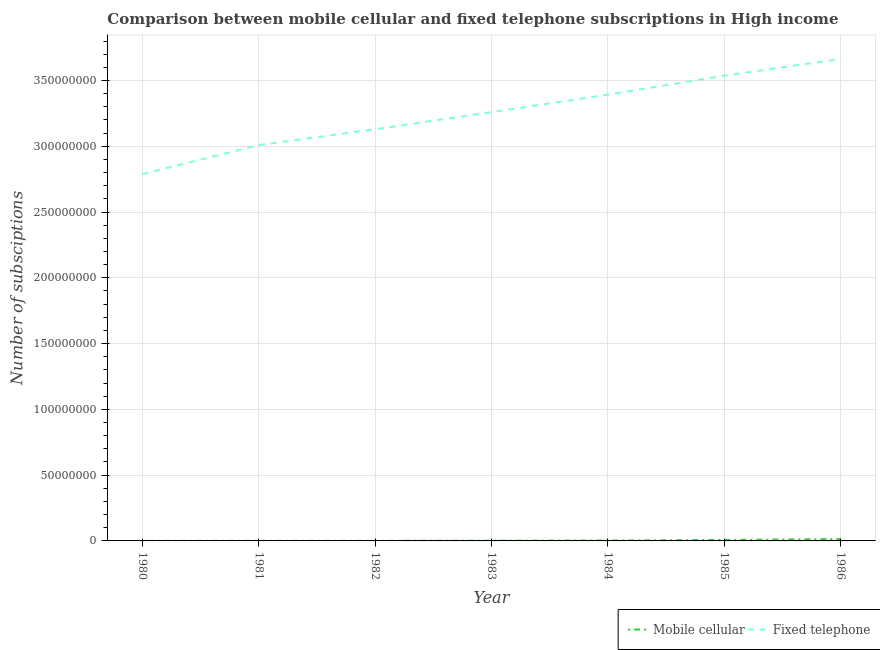What is the number of mobile cellular subscriptions in 1982?
Ensure brevity in your answer.  1.02e+05. Across all years, what is the maximum number of mobile cellular subscriptions?
Offer a terse response. 1.43e+06. Across all years, what is the minimum number of fixed telephone subscriptions?
Your answer should be very brief. 2.79e+08. In which year was the number of mobile cellular subscriptions maximum?
Offer a terse response. 1986. What is the total number of mobile cellular subscriptions in the graph?
Keep it short and to the point. 2.84e+06. What is the difference between the number of fixed telephone subscriptions in 1982 and that in 1986?
Your response must be concise. -5.34e+07. What is the difference between the number of mobile cellular subscriptions in 1980 and the number of fixed telephone subscriptions in 1986?
Your answer should be very brief. -3.66e+08. What is the average number of mobile cellular subscriptions per year?
Give a very brief answer. 4.05e+05. In the year 1980, what is the difference between the number of fixed telephone subscriptions and number of mobile cellular subscriptions?
Provide a short and direct response. 2.79e+08. What is the ratio of the number of fixed telephone subscriptions in 1983 to that in 1986?
Offer a very short reply. 0.89. Is the number of mobile cellular subscriptions in 1980 less than that in 1984?
Provide a short and direct response. Yes. Is the difference between the number of fixed telephone subscriptions in 1981 and 1983 greater than the difference between the number of mobile cellular subscriptions in 1981 and 1983?
Your answer should be compact. No. What is the difference between the highest and the second highest number of fixed telephone subscriptions?
Ensure brevity in your answer.  1.27e+07. What is the difference between the highest and the lowest number of fixed telephone subscriptions?
Provide a short and direct response. 8.75e+07. Is the sum of the number of fixed telephone subscriptions in 1980 and 1986 greater than the maximum number of mobile cellular subscriptions across all years?
Your response must be concise. Yes. What is the difference between two consecutive major ticks on the Y-axis?
Offer a very short reply. 5.00e+07. Are the values on the major ticks of Y-axis written in scientific E-notation?
Offer a very short reply. No. Does the graph contain any zero values?
Offer a terse response. No. Does the graph contain grids?
Provide a succinct answer. Yes. Where does the legend appear in the graph?
Your response must be concise. Bottom right. How many legend labels are there?
Your response must be concise. 2. What is the title of the graph?
Keep it short and to the point. Comparison between mobile cellular and fixed telephone subscriptions in High income. Does "Non-solid fuel" appear as one of the legend labels in the graph?
Ensure brevity in your answer.  No. What is the label or title of the X-axis?
Give a very brief answer. Year. What is the label or title of the Y-axis?
Provide a succinct answer. Number of subsciptions. What is the Number of subsciptions of Mobile cellular in 1980?
Give a very brief answer. 2.35e+04. What is the Number of subsciptions in Fixed telephone in 1980?
Offer a terse response. 2.79e+08. What is the Number of subsciptions in Mobile cellular in 1981?
Give a very brief answer. 6.36e+04. What is the Number of subsciptions of Fixed telephone in 1981?
Offer a very short reply. 3.01e+08. What is the Number of subsciptions in Mobile cellular in 1982?
Offer a terse response. 1.02e+05. What is the Number of subsciptions of Fixed telephone in 1982?
Keep it short and to the point. 3.13e+08. What is the Number of subsciptions of Mobile cellular in 1983?
Provide a succinct answer. 1.49e+05. What is the Number of subsciptions of Fixed telephone in 1983?
Provide a short and direct response. 3.26e+08. What is the Number of subsciptions of Mobile cellular in 1984?
Keep it short and to the point. 3.18e+05. What is the Number of subsciptions in Fixed telephone in 1984?
Offer a very short reply. 3.39e+08. What is the Number of subsciptions of Mobile cellular in 1985?
Your answer should be compact. 7.49e+05. What is the Number of subsciptions of Fixed telephone in 1985?
Offer a terse response. 3.54e+08. What is the Number of subsciptions in Mobile cellular in 1986?
Make the answer very short. 1.43e+06. What is the Number of subsciptions of Fixed telephone in 1986?
Offer a terse response. 3.66e+08. Across all years, what is the maximum Number of subsciptions in Mobile cellular?
Offer a very short reply. 1.43e+06. Across all years, what is the maximum Number of subsciptions in Fixed telephone?
Keep it short and to the point. 3.66e+08. Across all years, what is the minimum Number of subsciptions of Mobile cellular?
Make the answer very short. 2.35e+04. Across all years, what is the minimum Number of subsciptions of Fixed telephone?
Make the answer very short. 2.79e+08. What is the total Number of subsciptions in Mobile cellular in the graph?
Keep it short and to the point. 2.84e+06. What is the total Number of subsciptions of Fixed telephone in the graph?
Give a very brief answer. 2.28e+09. What is the difference between the Number of subsciptions of Mobile cellular in 1980 and that in 1981?
Make the answer very short. -4.01e+04. What is the difference between the Number of subsciptions of Fixed telephone in 1980 and that in 1981?
Offer a very short reply. -2.21e+07. What is the difference between the Number of subsciptions of Mobile cellular in 1980 and that in 1982?
Provide a succinct answer. -7.80e+04. What is the difference between the Number of subsciptions of Fixed telephone in 1980 and that in 1982?
Provide a short and direct response. -3.41e+07. What is the difference between the Number of subsciptions in Mobile cellular in 1980 and that in 1983?
Give a very brief answer. -1.25e+05. What is the difference between the Number of subsciptions of Fixed telephone in 1980 and that in 1983?
Offer a very short reply. -4.71e+07. What is the difference between the Number of subsciptions in Mobile cellular in 1980 and that in 1984?
Offer a very short reply. -2.94e+05. What is the difference between the Number of subsciptions of Fixed telephone in 1980 and that in 1984?
Your response must be concise. -6.04e+07. What is the difference between the Number of subsciptions in Mobile cellular in 1980 and that in 1985?
Make the answer very short. -7.25e+05. What is the difference between the Number of subsciptions in Fixed telephone in 1980 and that in 1985?
Your response must be concise. -7.48e+07. What is the difference between the Number of subsciptions in Mobile cellular in 1980 and that in 1986?
Your answer should be compact. -1.41e+06. What is the difference between the Number of subsciptions of Fixed telephone in 1980 and that in 1986?
Offer a very short reply. -8.75e+07. What is the difference between the Number of subsciptions of Mobile cellular in 1981 and that in 1982?
Give a very brief answer. -3.79e+04. What is the difference between the Number of subsciptions of Fixed telephone in 1981 and that in 1982?
Ensure brevity in your answer.  -1.21e+07. What is the difference between the Number of subsciptions in Mobile cellular in 1981 and that in 1983?
Your response must be concise. -8.53e+04. What is the difference between the Number of subsciptions in Fixed telephone in 1981 and that in 1983?
Your answer should be compact. -2.50e+07. What is the difference between the Number of subsciptions in Mobile cellular in 1981 and that in 1984?
Ensure brevity in your answer.  -2.54e+05. What is the difference between the Number of subsciptions of Fixed telephone in 1981 and that in 1984?
Offer a very short reply. -3.84e+07. What is the difference between the Number of subsciptions in Mobile cellular in 1981 and that in 1985?
Make the answer very short. -6.85e+05. What is the difference between the Number of subsciptions of Fixed telephone in 1981 and that in 1985?
Provide a succinct answer. -5.28e+07. What is the difference between the Number of subsciptions of Mobile cellular in 1981 and that in 1986?
Your response must be concise. -1.37e+06. What is the difference between the Number of subsciptions of Fixed telephone in 1981 and that in 1986?
Your answer should be compact. -6.55e+07. What is the difference between the Number of subsciptions of Mobile cellular in 1982 and that in 1983?
Keep it short and to the point. -4.73e+04. What is the difference between the Number of subsciptions of Fixed telephone in 1982 and that in 1983?
Offer a very short reply. -1.30e+07. What is the difference between the Number of subsciptions in Mobile cellular in 1982 and that in 1984?
Offer a terse response. -2.16e+05. What is the difference between the Number of subsciptions in Fixed telephone in 1982 and that in 1984?
Keep it short and to the point. -2.63e+07. What is the difference between the Number of subsciptions in Mobile cellular in 1982 and that in 1985?
Your answer should be compact. -6.47e+05. What is the difference between the Number of subsciptions in Fixed telephone in 1982 and that in 1985?
Give a very brief answer. -4.07e+07. What is the difference between the Number of subsciptions of Mobile cellular in 1982 and that in 1986?
Provide a short and direct response. -1.33e+06. What is the difference between the Number of subsciptions of Fixed telephone in 1982 and that in 1986?
Make the answer very short. -5.34e+07. What is the difference between the Number of subsciptions of Mobile cellular in 1983 and that in 1984?
Provide a succinct answer. -1.69e+05. What is the difference between the Number of subsciptions in Fixed telephone in 1983 and that in 1984?
Keep it short and to the point. -1.33e+07. What is the difference between the Number of subsciptions of Mobile cellular in 1983 and that in 1985?
Provide a succinct answer. -6.00e+05. What is the difference between the Number of subsciptions in Fixed telephone in 1983 and that in 1985?
Your response must be concise. -2.77e+07. What is the difference between the Number of subsciptions in Mobile cellular in 1983 and that in 1986?
Provide a short and direct response. -1.28e+06. What is the difference between the Number of subsciptions of Fixed telephone in 1983 and that in 1986?
Provide a short and direct response. -4.04e+07. What is the difference between the Number of subsciptions of Mobile cellular in 1984 and that in 1985?
Offer a terse response. -4.31e+05. What is the difference between the Number of subsciptions of Fixed telephone in 1984 and that in 1985?
Make the answer very short. -1.44e+07. What is the difference between the Number of subsciptions of Mobile cellular in 1984 and that in 1986?
Your answer should be compact. -1.12e+06. What is the difference between the Number of subsciptions in Fixed telephone in 1984 and that in 1986?
Keep it short and to the point. -2.71e+07. What is the difference between the Number of subsciptions in Mobile cellular in 1985 and that in 1986?
Provide a short and direct response. -6.85e+05. What is the difference between the Number of subsciptions in Fixed telephone in 1985 and that in 1986?
Your answer should be compact. -1.27e+07. What is the difference between the Number of subsciptions of Mobile cellular in 1980 and the Number of subsciptions of Fixed telephone in 1981?
Make the answer very short. -3.01e+08. What is the difference between the Number of subsciptions of Mobile cellular in 1980 and the Number of subsciptions of Fixed telephone in 1982?
Your response must be concise. -3.13e+08. What is the difference between the Number of subsciptions of Mobile cellular in 1980 and the Number of subsciptions of Fixed telephone in 1983?
Offer a very short reply. -3.26e+08. What is the difference between the Number of subsciptions of Mobile cellular in 1980 and the Number of subsciptions of Fixed telephone in 1984?
Ensure brevity in your answer.  -3.39e+08. What is the difference between the Number of subsciptions of Mobile cellular in 1980 and the Number of subsciptions of Fixed telephone in 1985?
Ensure brevity in your answer.  -3.54e+08. What is the difference between the Number of subsciptions in Mobile cellular in 1980 and the Number of subsciptions in Fixed telephone in 1986?
Provide a short and direct response. -3.66e+08. What is the difference between the Number of subsciptions of Mobile cellular in 1981 and the Number of subsciptions of Fixed telephone in 1982?
Your answer should be compact. -3.13e+08. What is the difference between the Number of subsciptions in Mobile cellular in 1981 and the Number of subsciptions in Fixed telephone in 1983?
Your answer should be compact. -3.26e+08. What is the difference between the Number of subsciptions in Mobile cellular in 1981 and the Number of subsciptions in Fixed telephone in 1984?
Offer a terse response. -3.39e+08. What is the difference between the Number of subsciptions of Mobile cellular in 1981 and the Number of subsciptions of Fixed telephone in 1985?
Give a very brief answer. -3.54e+08. What is the difference between the Number of subsciptions in Mobile cellular in 1981 and the Number of subsciptions in Fixed telephone in 1986?
Your answer should be compact. -3.66e+08. What is the difference between the Number of subsciptions of Mobile cellular in 1982 and the Number of subsciptions of Fixed telephone in 1983?
Your answer should be very brief. -3.26e+08. What is the difference between the Number of subsciptions in Mobile cellular in 1982 and the Number of subsciptions in Fixed telephone in 1984?
Your response must be concise. -3.39e+08. What is the difference between the Number of subsciptions in Mobile cellular in 1982 and the Number of subsciptions in Fixed telephone in 1985?
Provide a succinct answer. -3.54e+08. What is the difference between the Number of subsciptions of Mobile cellular in 1982 and the Number of subsciptions of Fixed telephone in 1986?
Ensure brevity in your answer.  -3.66e+08. What is the difference between the Number of subsciptions in Mobile cellular in 1983 and the Number of subsciptions in Fixed telephone in 1984?
Give a very brief answer. -3.39e+08. What is the difference between the Number of subsciptions of Mobile cellular in 1983 and the Number of subsciptions of Fixed telephone in 1985?
Make the answer very short. -3.54e+08. What is the difference between the Number of subsciptions of Mobile cellular in 1983 and the Number of subsciptions of Fixed telephone in 1986?
Keep it short and to the point. -3.66e+08. What is the difference between the Number of subsciptions of Mobile cellular in 1984 and the Number of subsciptions of Fixed telephone in 1985?
Provide a short and direct response. -3.53e+08. What is the difference between the Number of subsciptions of Mobile cellular in 1984 and the Number of subsciptions of Fixed telephone in 1986?
Provide a succinct answer. -3.66e+08. What is the difference between the Number of subsciptions of Mobile cellular in 1985 and the Number of subsciptions of Fixed telephone in 1986?
Provide a short and direct response. -3.66e+08. What is the average Number of subsciptions in Mobile cellular per year?
Give a very brief answer. 4.05e+05. What is the average Number of subsciptions in Fixed telephone per year?
Offer a very short reply. 3.25e+08. In the year 1980, what is the difference between the Number of subsciptions of Mobile cellular and Number of subsciptions of Fixed telephone?
Your answer should be very brief. -2.79e+08. In the year 1981, what is the difference between the Number of subsciptions of Mobile cellular and Number of subsciptions of Fixed telephone?
Your answer should be compact. -3.01e+08. In the year 1982, what is the difference between the Number of subsciptions of Mobile cellular and Number of subsciptions of Fixed telephone?
Provide a short and direct response. -3.13e+08. In the year 1983, what is the difference between the Number of subsciptions of Mobile cellular and Number of subsciptions of Fixed telephone?
Offer a terse response. -3.26e+08. In the year 1984, what is the difference between the Number of subsciptions in Mobile cellular and Number of subsciptions in Fixed telephone?
Keep it short and to the point. -3.39e+08. In the year 1985, what is the difference between the Number of subsciptions in Mobile cellular and Number of subsciptions in Fixed telephone?
Your answer should be very brief. -3.53e+08. In the year 1986, what is the difference between the Number of subsciptions of Mobile cellular and Number of subsciptions of Fixed telephone?
Offer a very short reply. -3.65e+08. What is the ratio of the Number of subsciptions in Mobile cellular in 1980 to that in 1981?
Provide a short and direct response. 0.37. What is the ratio of the Number of subsciptions of Fixed telephone in 1980 to that in 1981?
Your response must be concise. 0.93. What is the ratio of the Number of subsciptions of Mobile cellular in 1980 to that in 1982?
Provide a succinct answer. 0.23. What is the ratio of the Number of subsciptions in Fixed telephone in 1980 to that in 1982?
Your answer should be compact. 0.89. What is the ratio of the Number of subsciptions in Mobile cellular in 1980 to that in 1983?
Give a very brief answer. 0.16. What is the ratio of the Number of subsciptions of Fixed telephone in 1980 to that in 1983?
Offer a very short reply. 0.86. What is the ratio of the Number of subsciptions of Mobile cellular in 1980 to that in 1984?
Make the answer very short. 0.07. What is the ratio of the Number of subsciptions of Fixed telephone in 1980 to that in 1984?
Provide a short and direct response. 0.82. What is the ratio of the Number of subsciptions of Mobile cellular in 1980 to that in 1985?
Make the answer very short. 0.03. What is the ratio of the Number of subsciptions in Fixed telephone in 1980 to that in 1985?
Provide a succinct answer. 0.79. What is the ratio of the Number of subsciptions of Mobile cellular in 1980 to that in 1986?
Provide a succinct answer. 0.02. What is the ratio of the Number of subsciptions in Fixed telephone in 1980 to that in 1986?
Keep it short and to the point. 0.76. What is the ratio of the Number of subsciptions in Mobile cellular in 1981 to that in 1982?
Your response must be concise. 0.63. What is the ratio of the Number of subsciptions in Fixed telephone in 1981 to that in 1982?
Provide a succinct answer. 0.96. What is the ratio of the Number of subsciptions in Mobile cellular in 1981 to that in 1983?
Offer a terse response. 0.43. What is the ratio of the Number of subsciptions of Fixed telephone in 1981 to that in 1983?
Give a very brief answer. 0.92. What is the ratio of the Number of subsciptions in Mobile cellular in 1981 to that in 1984?
Offer a very short reply. 0.2. What is the ratio of the Number of subsciptions in Fixed telephone in 1981 to that in 1984?
Keep it short and to the point. 0.89. What is the ratio of the Number of subsciptions of Mobile cellular in 1981 to that in 1985?
Your response must be concise. 0.08. What is the ratio of the Number of subsciptions of Fixed telephone in 1981 to that in 1985?
Offer a very short reply. 0.85. What is the ratio of the Number of subsciptions in Mobile cellular in 1981 to that in 1986?
Your answer should be compact. 0.04. What is the ratio of the Number of subsciptions in Fixed telephone in 1981 to that in 1986?
Provide a succinct answer. 0.82. What is the ratio of the Number of subsciptions in Mobile cellular in 1982 to that in 1983?
Provide a succinct answer. 0.68. What is the ratio of the Number of subsciptions of Fixed telephone in 1982 to that in 1983?
Offer a very short reply. 0.96. What is the ratio of the Number of subsciptions of Mobile cellular in 1982 to that in 1984?
Keep it short and to the point. 0.32. What is the ratio of the Number of subsciptions in Fixed telephone in 1982 to that in 1984?
Provide a succinct answer. 0.92. What is the ratio of the Number of subsciptions in Mobile cellular in 1982 to that in 1985?
Keep it short and to the point. 0.14. What is the ratio of the Number of subsciptions of Fixed telephone in 1982 to that in 1985?
Offer a very short reply. 0.88. What is the ratio of the Number of subsciptions of Mobile cellular in 1982 to that in 1986?
Provide a succinct answer. 0.07. What is the ratio of the Number of subsciptions of Fixed telephone in 1982 to that in 1986?
Offer a terse response. 0.85. What is the ratio of the Number of subsciptions in Mobile cellular in 1983 to that in 1984?
Ensure brevity in your answer.  0.47. What is the ratio of the Number of subsciptions in Fixed telephone in 1983 to that in 1984?
Make the answer very short. 0.96. What is the ratio of the Number of subsciptions in Mobile cellular in 1983 to that in 1985?
Your response must be concise. 0.2. What is the ratio of the Number of subsciptions in Fixed telephone in 1983 to that in 1985?
Your answer should be very brief. 0.92. What is the ratio of the Number of subsciptions in Mobile cellular in 1983 to that in 1986?
Provide a succinct answer. 0.1. What is the ratio of the Number of subsciptions in Fixed telephone in 1983 to that in 1986?
Ensure brevity in your answer.  0.89. What is the ratio of the Number of subsciptions in Mobile cellular in 1984 to that in 1985?
Offer a terse response. 0.42. What is the ratio of the Number of subsciptions in Fixed telephone in 1984 to that in 1985?
Give a very brief answer. 0.96. What is the ratio of the Number of subsciptions of Mobile cellular in 1984 to that in 1986?
Offer a terse response. 0.22. What is the ratio of the Number of subsciptions in Fixed telephone in 1984 to that in 1986?
Offer a terse response. 0.93. What is the ratio of the Number of subsciptions of Mobile cellular in 1985 to that in 1986?
Ensure brevity in your answer.  0.52. What is the ratio of the Number of subsciptions in Fixed telephone in 1985 to that in 1986?
Give a very brief answer. 0.97. What is the difference between the highest and the second highest Number of subsciptions of Mobile cellular?
Your answer should be compact. 6.85e+05. What is the difference between the highest and the second highest Number of subsciptions in Fixed telephone?
Offer a terse response. 1.27e+07. What is the difference between the highest and the lowest Number of subsciptions of Mobile cellular?
Keep it short and to the point. 1.41e+06. What is the difference between the highest and the lowest Number of subsciptions of Fixed telephone?
Give a very brief answer. 8.75e+07. 